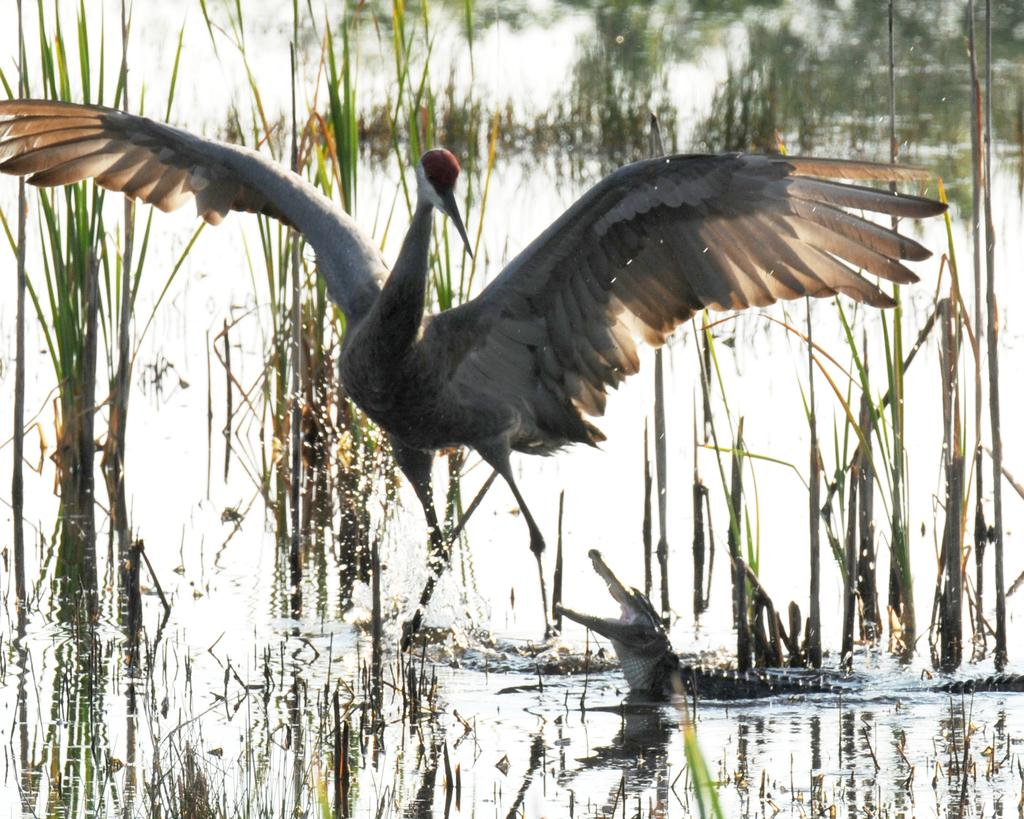What animal is in the water in the image? There is a crocodile in the water in the image. What type of vegetation can be seen in the image? There is grass visible in the image. What other animal is present in the image? There is a swan in the image. What type of cord is being used to control the movements of the crocodile in the image? There is no cord present in the image, and the crocodile is not being controlled. 